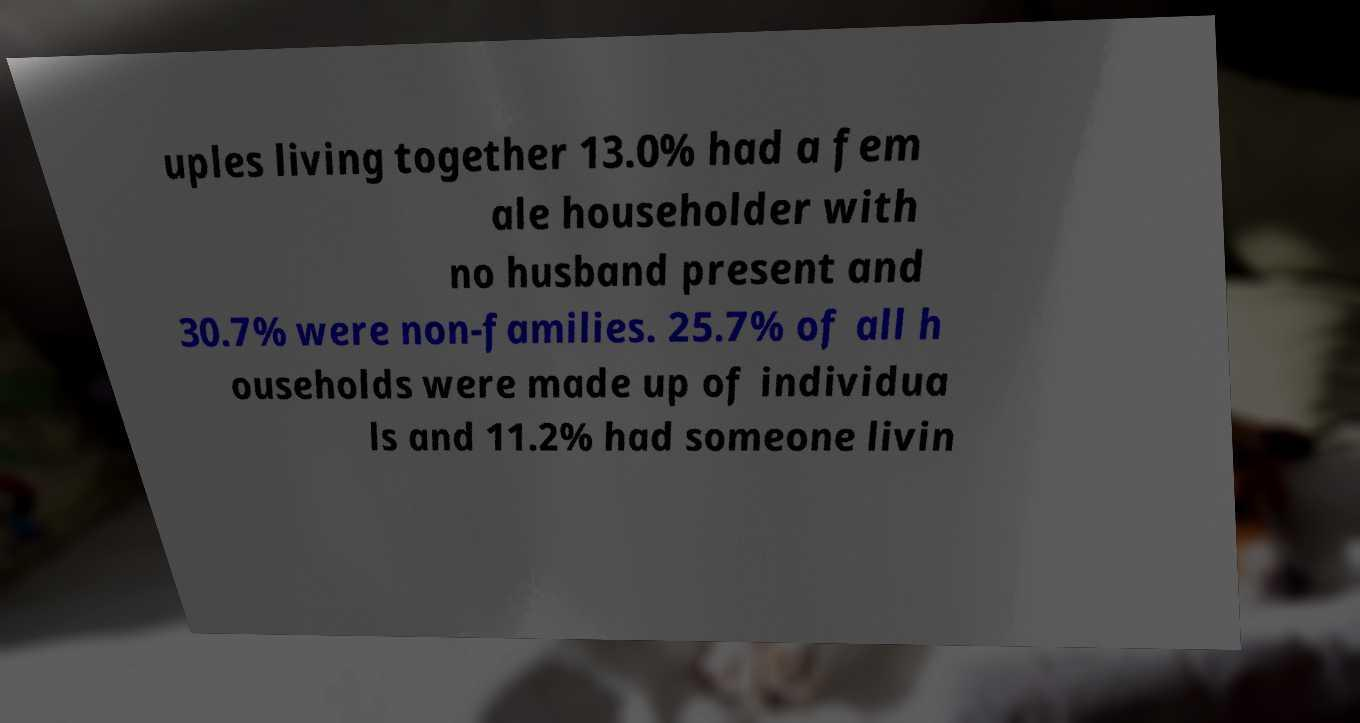What messages or text are displayed in this image? I need them in a readable, typed format. uples living together 13.0% had a fem ale householder with no husband present and 30.7% were non-families. 25.7% of all h ouseholds were made up of individua ls and 11.2% had someone livin 